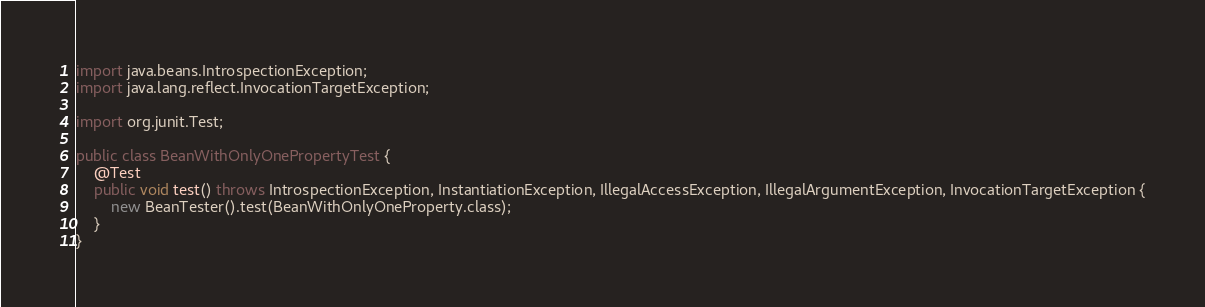Convert code to text. <code><loc_0><loc_0><loc_500><loc_500><_Java_>import java.beans.IntrospectionException;
import java.lang.reflect.InvocationTargetException;

import org.junit.Test;

public class BeanWithOnlyOnePropertyTest {
    @Test
    public void test() throws IntrospectionException, InstantiationException, IllegalAccessException, IllegalArgumentException, InvocationTargetException {
        new BeanTester().test(BeanWithOnlyOneProperty.class);
    }
}
</code> 